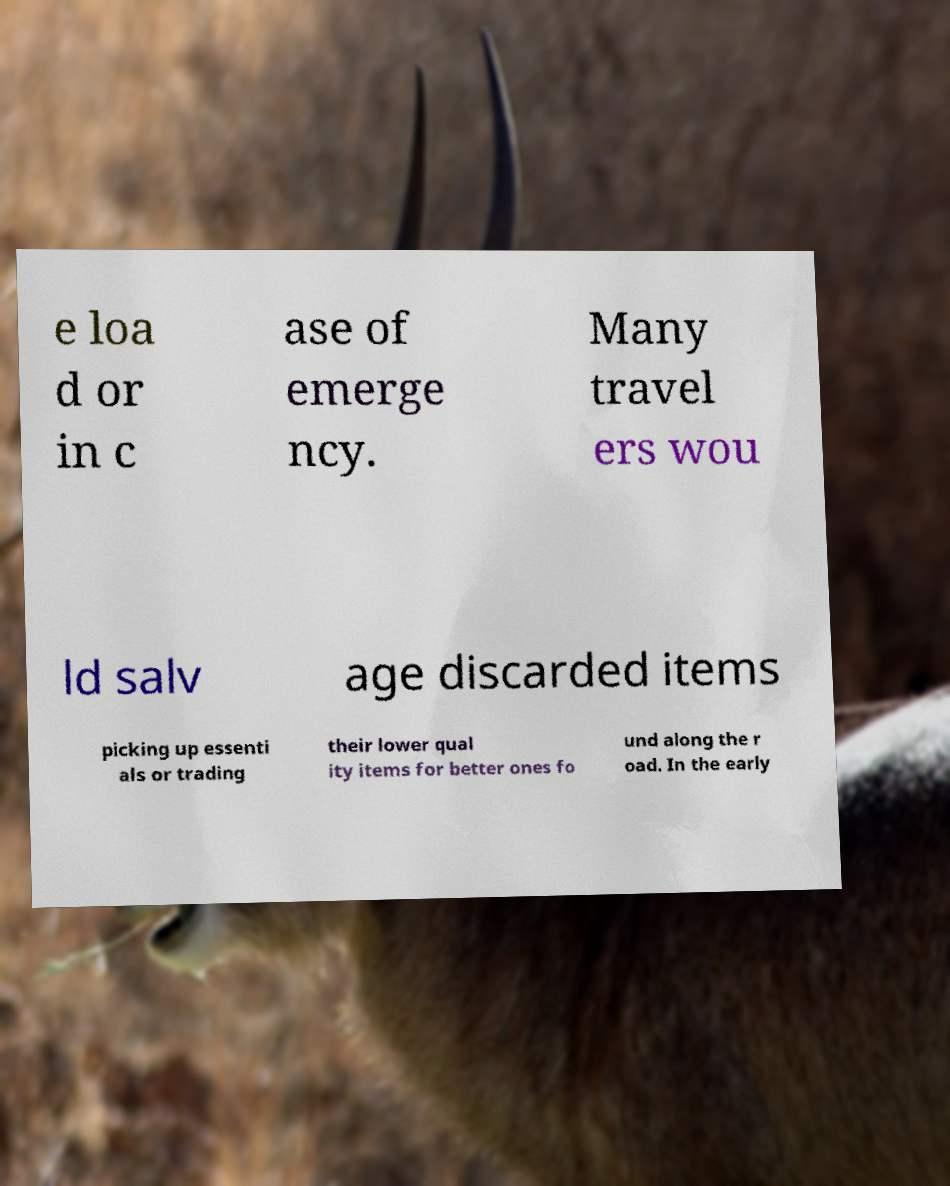Please identify and transcribe the text found in this image. e loa d or in c ase of emerge ncy. Many travel ers wou ld salv age discarded items picking up essenti als or trading their lower qual ity items for better ones fo und along the r oad. In the early 